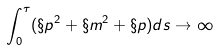<formula> <loc_0><loc_0><loc_500><loc_500>\int _ { 0 } ^ { \tau } ( \S p ^ { 2 } + \S m ^ { 2 } + \S p ) d s \rightarrow \infty</formula> 